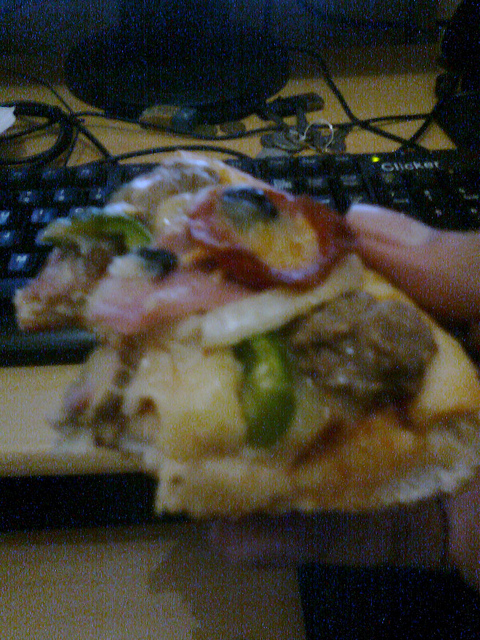Is it an outdoor scene? No, the setting does not appear to be outdoors. It suggests an indoor environment, possibly near a work desk. 